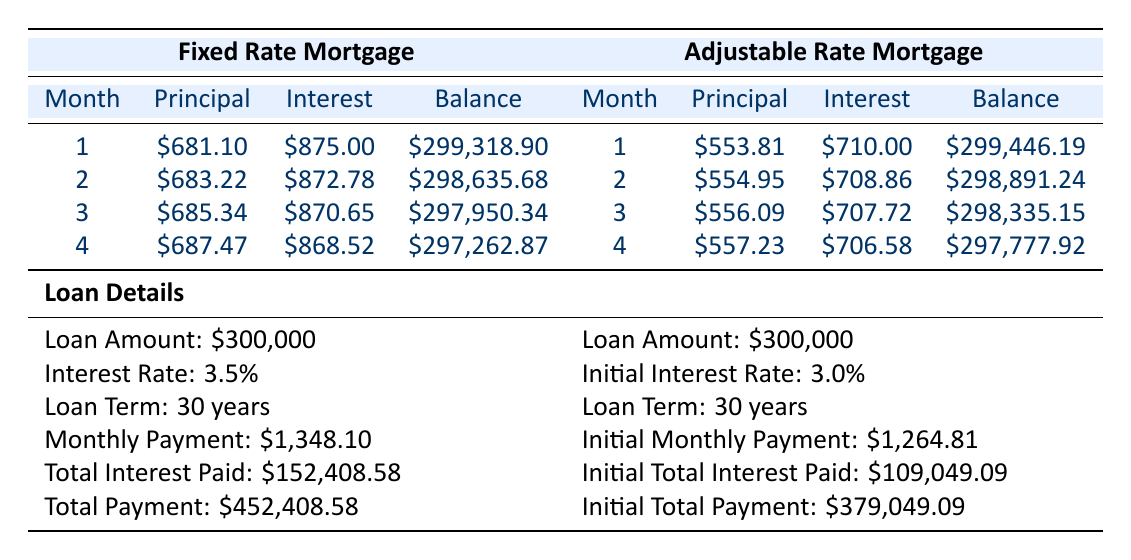What is the monthly payment for the Fixed Rate Mortgage? From the table, the monthly payment listed under Fixed Rate Mortgage is $1,348.10.
Answer: $1,348.10 What is the total interest paid for the Adjustable Rate Mortgage? The total interest paid for the Adjustable Rate Mortgage is indicated in the table as $109,049.09.
Answer: $109,049.09 Which mortgage has a higher initial monthly payment, Fixed Rate or Adjustable Rate? The Fixed Rate Mortgage has a monthly payment of $1,348.10, while the Adjustable Rate Mortgage has an initial monthly payment of $1,264.81. Therefore, the Fixed Rate Mortgage has the higher initial monthly payment.
Answer: Fixed Rate Mortgage What is the total payment made for the Fixed Rate Mortgage? The total payment for the Fixed Rate Mortgage according to the table is $452,408.58.
Answer: $452,408.58 How much more total interest is paid for the Fixed Rate Mortgage compared to the Adjustable Rate Mortgage? Total interest for Fixed Rate Mortgage is $152,408.58 and for Adjustable Rate Mortgage is $109,049.09. The difference is $152,408.58 - $109,049.09 = $43,359.49.
Answer: $43,359.49 Does the Adjustable Rate Mortgage have a higher estimated interest rate after adjustment than the Fixed Rate Mortgage? The estimated interest rate after adjustment for the Adjustable Rate Mortgage is 4.5%, while the Fixed Rate Mortgage has a fixed interest rate of 3.5%. Therefore, the statement is true.
Answer: Yes What is the principal payment for the third month of the Fixed Rate Mortgage? In the table, the principal payment for the third month of the Fixed Rate Mortgage is $685.34.
Answer: $685.34 What is the total payment made for the Adjustable Rate Mortgage? The total payment for the Adjustable Rate Mortgage is given in the table as $379,049.09.
Answer: $379,049.09 How much does the principal payment increase from the first to the fourth month for the Fixed Rate Mortgage? The principal payment for the first month is $681.10 and for the fourth month is $687.47. The increase is $687.47 - $681.10 = $6.37.
Answer: $6.37 